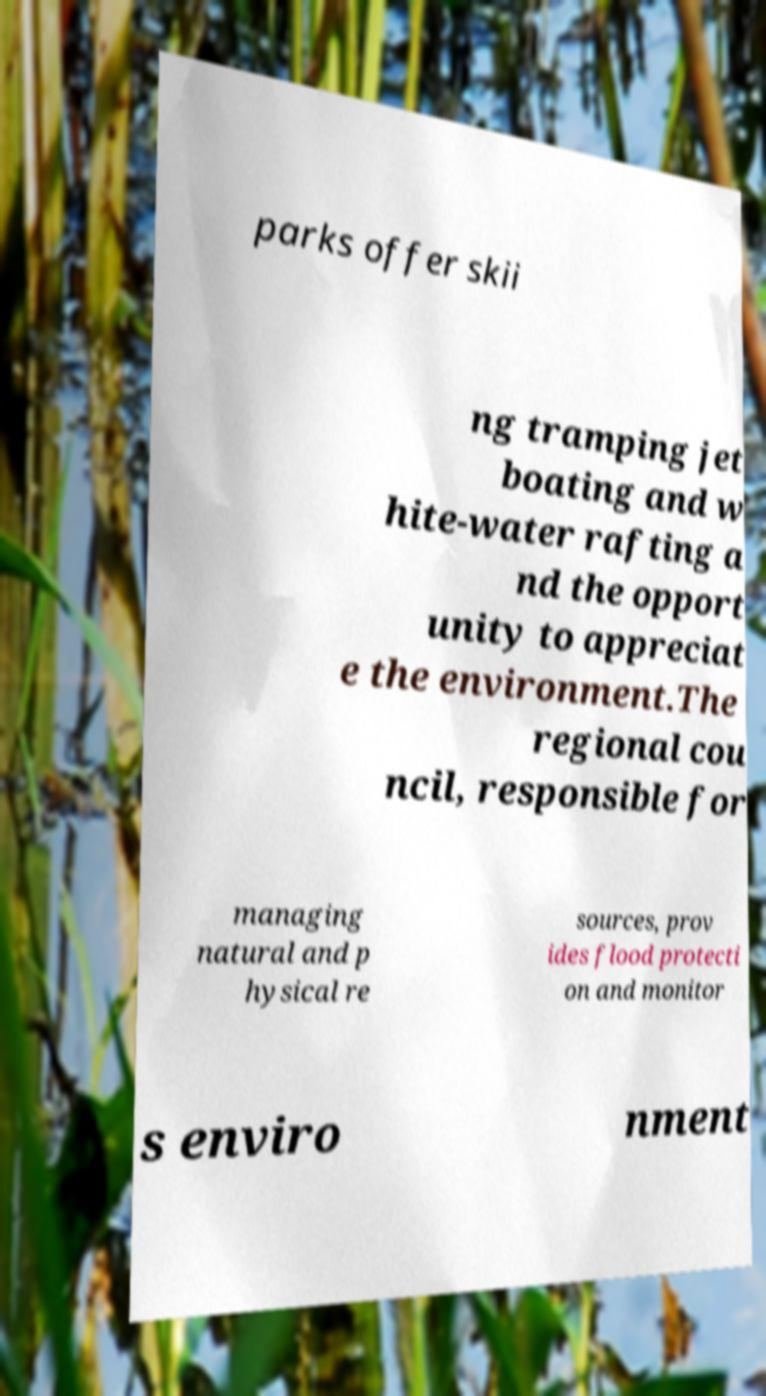What messages or text are displayed in this image? I need them in a readable, typed format. parks offer skii ng tramping jet boating and w hite-water rafting a nd the opport unity to appreciat e the environment.The regional cou ncil, responsible for managing natural and p hysical re sources, prov ides flood protecti on and monitor s enviro nment 